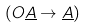Convert formula to latex. <formula><loc_0><loc_0><loc_500><loc_500>( O \underline { A } \rightarrow \underline { A } )</formula> 